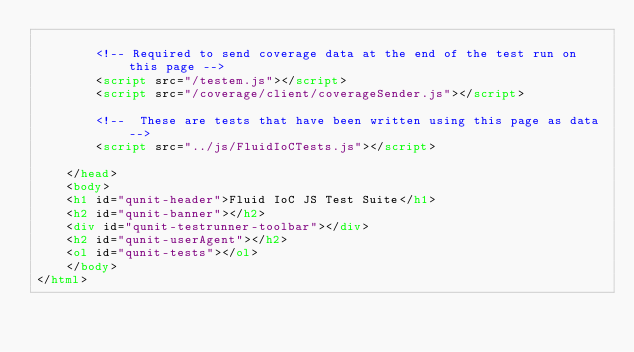<code> <loc_0><loc_0><loc_500><loc_500><_HTML_>
        <!-- Required to send coverage data at the end of the test run on this page -->
        <script src="/testem.js"></script>
        <script src="/coverage/client/coverageSender.js"></script>

        <!--  These are tests that have been written using this page as data -->
        <script src="../js/FluidIoCTests.js"></script>

    </head>
    <body>
    <h1 id="qunit-header">Fluid IoC JS Test Suite</h1>
    <h2 id="qunit-banner"></h2>
    <div id="qunit-testrunner-toolbar"></div>
    <h2 id="qunit-userAgent"></h2>
    <ol id="qunit-tests"></ol>
    </body>
</html>
</code> 